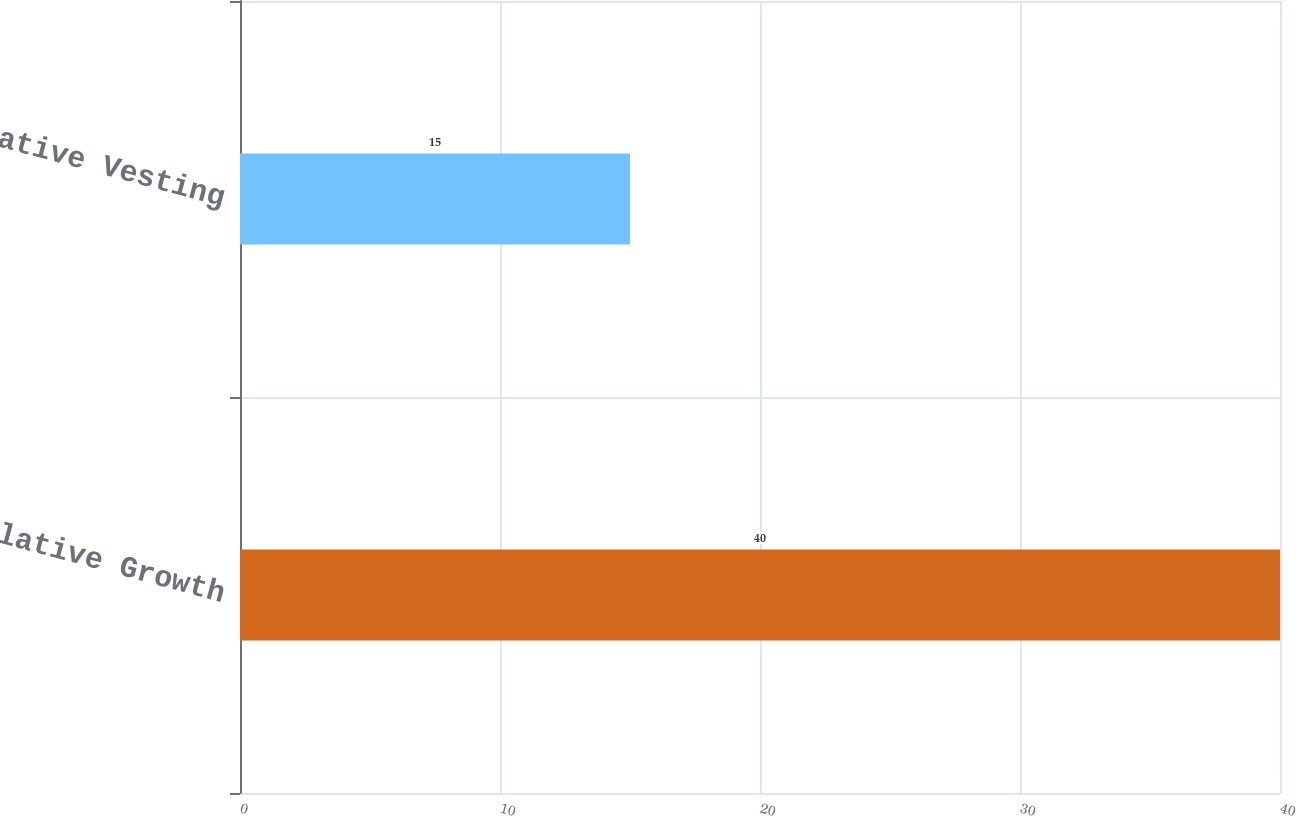<chart> <loc_0><loc_0><loc_500><loc_500><bar_chart><fcel>Cumulative Growth<fcel>Cumulative Vesting<nl><fcel>40<fcel>15<nl></chart> 